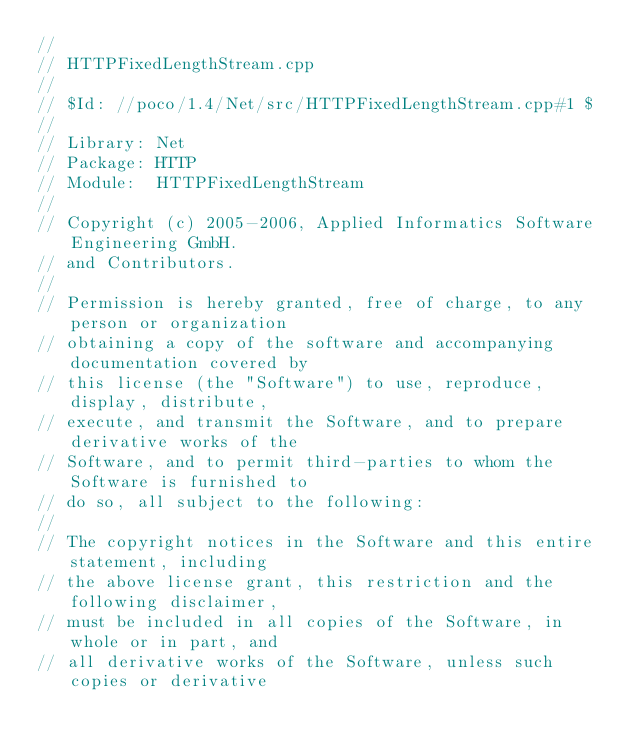Convert code to text. <code><loc_0><loc_0><loc_500><loc_500><_C++_>//
// HTTPFixedLengthStream.cpp
//
// $Id: //poco/1.4/Net/src/HTTPFixedLengthStream.cpp#1 $
//
// Library: Net
// Package: HTTP
// Module:  HTTPFixedLengthStream
//
// Copyright (c) 2005-2006, Applied Informatics Software Engineering GmbH.
// and Contributors.
//
// Permission is hereby granted, free of charge, to any person or organization
// obtaining a copy of the software and accompanying documentation covered by
// this license (the "Software") to use, reproduce, display, distribute,
// execute, and transmit the Software, and to prepare derivative works of the
// Software, and to permit third-parties to whom the Software is furnished to
// do so, all subject to the following:
// 
// The copyright notices in the Software and this entire statement, including
// the above license grant, this restriction and the following disclaimer,
// must be included in all copies of the Software, in whole or in part, and
// all derivative works of the Software, unless such copies or derivative</code> 